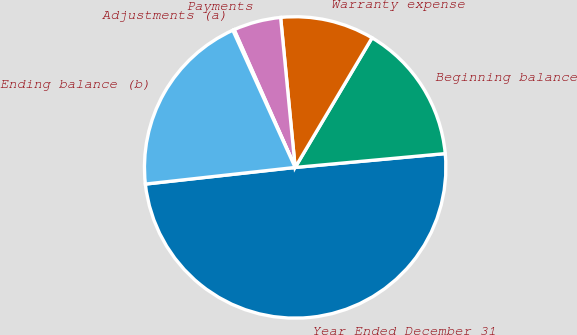<chart> <loc_0><loc_0><loc_500><loc_500><pie_chart><fcel>Year Ended December 31<fcel>Beginning balance<fcel>Warranty expense<fcel>Payments<fcel>Adjustments (a)<fcel>Ending balance (b)<nl><fcel>49.7%<fcel>15.01%<fcel>10.06%<fcel>5.1%<fcel>0.15%<fcel>19.97%<nl></chart> 